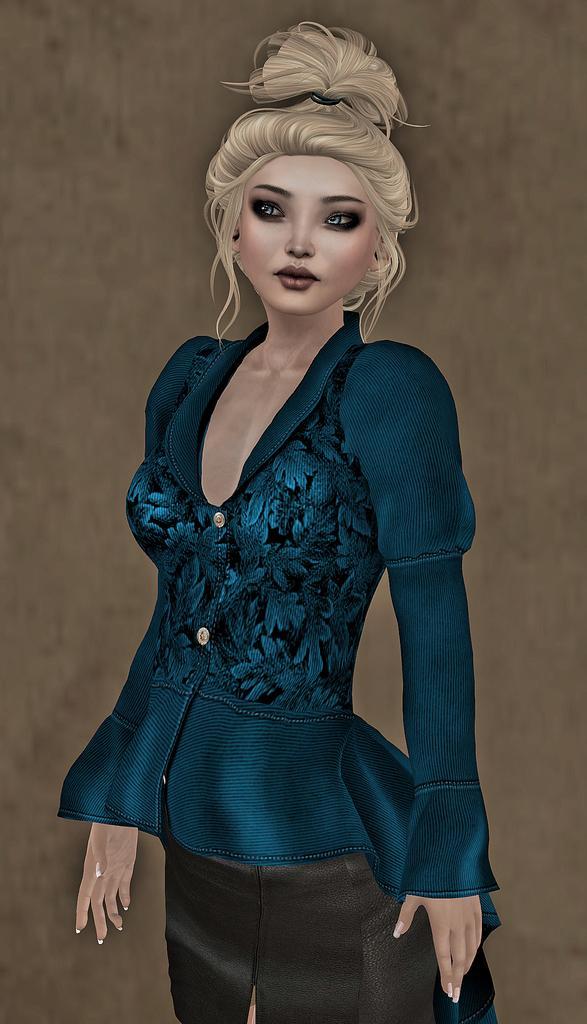Could you give a brief overview of what you see in this image? This is an animated image. We can see a lady and the background. 